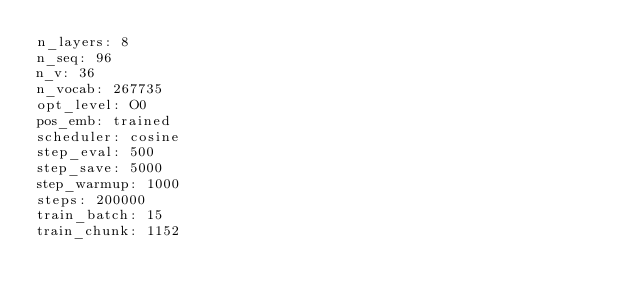<code> <loc_0><loc_0><loc_500><loc_500><_YAML_>n_layers: 8
n_seq: 96
n_v: 36
n_vocab: 267735
opt_level: O0
pos_emb: trained
scheduler: cosine
step_eval: 500
step_save: 5000
step_warmup: 1000
steps: 200000
train_batch: 15
train_chunk: 1152
</code> 